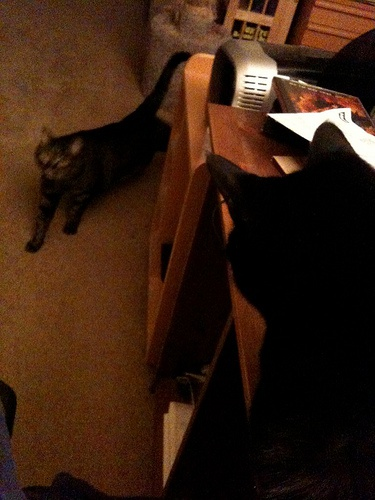Describe the objects in this image and their specific colors. I can see cat in black, maroon, ivory, and brown tones, cat in black and maroon tones, book in black, ivory, darkgray, and maroon tones, book in black, maroon, and brown tones, and book in black, brown, gray, and maroon tones in this image. 